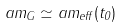<formula> <loc_0><loc_0><loc_500><loc_500>a m _ { G } \simeq a m _ { e f f } ( t _ { 0 } )</formula> 